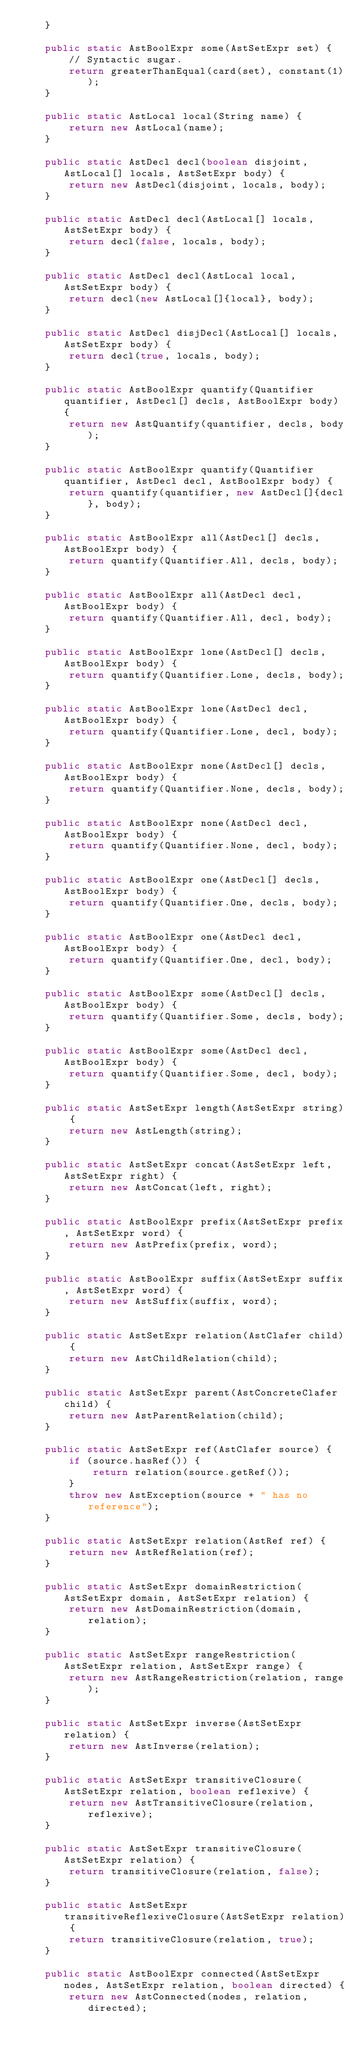<code> <loc_0><loc_0><loc_500><loc_500><_Java_>    }

    public static AstBoolExpr some(AstSetExpr set) {
        // Syntactic sugar.
        return greaterThanEqual(card(set), constant(1));
    }

    public static AstLocal local(String name) {
        return new AstLocal(name);
    }

    public static AstDecl decl(boolean disjoint, AstLocal[] locals, AstSetExpr body) {
        return new AstDecl(disjoint, locals, body);
    }

    public static AstDecl decl(AstLocal[] locals, AstSetExpr body) {
        return decl(false, locals, body);
    }

    public static AstDecl decl(AstLocal local, AstSetExpr body) {
        return decl(new AstLocal[]{local}, body);
    }

    public static AstDecl disjDecl(AstLocal[] locals, AstSetExpr body) {
        return decl(true, locals, body);
    }

    public static AstBoolExpr quantify(Quantifier quantifier, AstDecl[] decls, AstBoolExpr body) {
        return new AstQuantify(quantifier, decls, body);
    }

    public static AstBoolExpr quantify(Quantifier quantifier, AstDecl decl, AstBoolExpr body) {
        return quantify(quantifier, new AstDecl[]{decl}, body);
    }

    public static AstBoolExpr all(AstDecl[] decls, AstBoolExpr body) {
        return quantify(Quantifier.All, decls, body);
    }

    public static AstBoolExpr all(AstDecl decl, AstBoolExpr body) {
        return quantify(Quantifier.All, decl, body);
    }

    public static AstBoolExpr lone(AstDecl[] decls, AstBoolExpr body) {
        return quantify(Quantifier.Lone, decls, body);
    }

    public static AstBoolExpr lone(AstDecl decl, AstBoolExpr body) {
        return quantify(Quantifier.Lone, decl, body);
    }

    public static AstBoolExpr none(AstDecl[] decls, AstBoolExpr body) {
        return quantify(Quantifier.None, decls, body);
    }

    public static AstBoolExpr none(AstDecl decl, AstBoolExpr body) {
        return quantify(Quantifier.None, decl, body);
    }

    public static AstBoolExpr one(AstDecl[] decls, AstBoolExpr body) {
        return quantify(Quantifier.One, decls, body);
    }

    public static AstBoolExpr one(AstDecl decl, AstBoolExpr body) {
        return quantify(Quantifier.One, decl, body);
    }

    public static AstBoolExpr some(AstDecl[] decls, AstBoolExpr body) {
        return quantify(Quantifier.Some, decls, body);
    }

    public static AstBoolExpr some(AstDecl decl, AstBoolExpr body) {
        return quantify(Quantifier.Some, decl, body);
    }

    public static AstSetExpr length(AstSetExpr string) {
        return new AstLength(string);
    }

    public static AstSetExpr concat(AstSetExpr left, AstSetExpr right) {
        return new AstConcat(left, right);
    }

    public static AstBoolExpr prefix(AstSetExpr prefix, AstSetExpr word) {
        return new AstPrefix(prefix, word);
    }

    public static AstBoolExpr suffix(AstSetExpr suffix, AstSetExpr word) {
        return new AstSuffix(suffix, word);
    }

    public static AstSetExpr relation(AstClafer child) {
        return new AstChildRelation(child);
    }

    public static AstSetExpr parent(AstConcreteClafer child) {
        return new AstParentRelation(child);
    }

    public static AstSetExpr ref(AstClafer source) {
        if (source.hasRef()) {
            return relation(source.getRef());
        }
        throw new AstException(source + " has no reference");
    }

    public static AstSetExpr relation(AstRef ref) {
        return new AstRefRelation(ref);
    }

    public static AstSetExpr domainRestriction(AstSetExpr domain, AstSetExpr relation) {
        return new AstDomainRestriction(domain, relation);
    }

    public static AstSetExpr rangeRestriction(AstSetExpr relation, AstSetExpr range) {
        return new AstRangeRestriction(relation, range);
    }

    public static AstSetExpr inverse(AstSetExpr relation) {
        return new AstInverse(relation);
    }

    public static AstSetExpr transitiveClosure(AstSetExpr relation, boolean reflexive) {
        return new AstTransitiveClosure(relation, reflexive);
    }

    public static AstSetExpr transitiveClosure(AstSetExpr relation) {
        return transitiveClosure(relation, false);
    }

    public static AstSetExpr transitiveReflexiveClosure(AstSetExpr relation) {
        return transitiveClosure(relation, true);
    }

    public static AstBoolExpr connected(AstSetExpr nodes, AstSetExpr relation, boolean directed) {
        return new AstConnected(nodes, relation, directed);</code> 